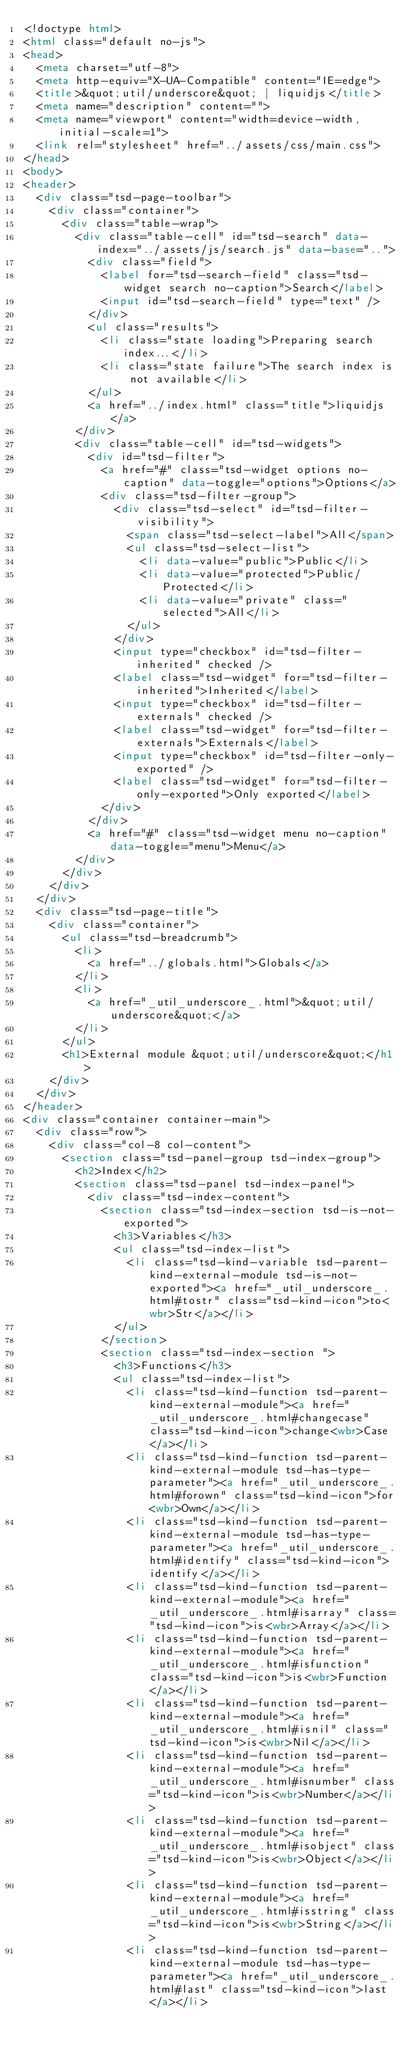<code> <loc_0><loc_0><loc_500><loc_500><_HTML_><!doctype html>
<html class="default no-js">
<head>
	<meta charset="utf-8">
	<meta http-equiv="X-UA-Compatible" content="IE=edge">
	<title>&quot;util/underscore&quot; | liquidjs</title>
	<meta name="description" content="">
	<meta name="viewport" content="width=device-width, initial-scale=1">
	<link rel="stylesheet" href="../assets/css/main.css">
</head>
<body>
<header>
	<div class="tsd-page-toolbar">
		<div class="container">
			<div class="table-wrap">
				<div class="table-cell" id="tsd-search" data-index="../assets/js/search.js" data-base="..">
					<div class="field">
						<label for="tsd-search-field" class="tsd-widget search no-caption">Search</label>
						<input id="tsd-search-field" type="text" />
					</div>
					<ul class="results">
						<li class="state loading">Preparing search index...</li>
						<li class="state failure">The search index is not available</li>
					</ul>
					<a href="../index.html" class="title">liquidjs</a>
				</div>
				<div class="table-cell" id="tsd-widgets">
					<div id="tsd-filter">
						<a href="#" class="tsd-widget options no-caption" data-toggle="options">Options</a>
						<div class="tsd-filter-group">
							<div class="tsd-select" id="tsd-filter-visibility">
								<span class="tsd-select-label">All</span>
								<ul class="tsd-select-list">
									<li data-value="public">Public</li>
									<li data-value="protected">Public/Protected</li>
									<li data-value="private" class="selected">All</li>
								</ul>
							</div>
							<input type="checkbox" id="tsd-filter-inherited" checked />
							<label class="tsd-widget" for="tsd-filter-inherited">Inherited</label>
							<input type="checkbox" id="tsd-filter-externals" checked />
							<label class="tsd-widget" for="tsd-filter-externals">Externals</label>
							<input type="checkbox" id="tsd-filter-only-exported" />
							<label class="tsd-widget" for="tsd-filter-only-exported">Only exported</label>
						</div>
					</div>
					<a href="#" class="tsd-widget menu no-caption" data-toggle="menu">Menu</a>
				</div>
			</div>
		</div>
	</div>
	<div class="tsd-page-title">
		<div class="container">
			<ul class="tsd-breadcrumb">
				<li>
					<a href="../globals.html">Globals</a>
				</li>
				<li>
					<a href="_util_underscore_.html">&quot;util/underscore&quot;</a>
				</li>
			</ul>
			<h1>External module &quot;util/underscore&quot;</h1>
		</div>
	</div>
</header>
<div class="container container-main">
	<div class="row">
		<div class="col-8 col-content">
			<section class="tsd-panel-group tsd-index-group">
				<h2>Index</h2>
				<section class="tsd-panel tsd-index-panel">
					<div class="tsd-index-content">
						<section class="tsd-index-section tsd-is-not-exported">
							<h3>Variables</h3>
							<ul class="tsd-index-list">
								<li class="tsd-kind-variable tsd-parent-kind-external-module tsd-is-not-exported"><a href="_util_underscore_.html#tostr" class="tsd-kind-icon">to<wbr>Str</a></li>
							</ul>
						</section>
						<section class="tsd-index-section ">
							<h3>Functions</h3>
							<ul class="tsd-index-list">
								<li class="tsd-kind-function tsd-parent-kind-external-module"><a href="_util_underscore_.html#changecase" class="tsd-kind-icon">change<wbr>Case</a></li>
								<li class="tsd-kind-function tsd-parent-kind-external-module tsd-has-type-parameter"><a href="_util_underscore_.html#forown" class="tsd-kind-icon">for<wbr>Own</a></li>
								<li class="tsd-kind-function tsd-parent-kind-external-module tsd-has-type-parameter"><a href="_util_underscore_.html#identify" class="tsd-kind-icon">identify</a></li>
								<li class="tsd-kind-function tsd-parent-kind-external-module"><a href="_util_underscore_.html#isarray" class="tsd-kind-icon">is<wbr>Array</a></li>
								<li class="tsd-kind-function tsd-parent-kind-external-module"><a href="_util_underscore_.html#isfunction" class="tsd-kind-icon">is<wbr>Function</a></li>
								<li class="tsd-kind-function tsd-parent-kind-external-module"><a href="_util_underscore_.html#isnil" class="tsd-kind-icon">is<wbr>Nil</a></li>
								<li class="tsd-kind-function tsd-parent-kind-external-module"><a href="_util_underscore_.html#isnumber" class="tsd-kind-icon">is<wbr>Number</a></li>
								<li class="tsd-kind-function tsd-parent-kind-external-module"><a href="_util_underscore_.html#isobject" class="tsd-kind-icon">is<wbr>Object</a></li>
								<li class="tsd-kind-function tsd-parent-kind-external-module"><a href="_util_underscore_.html#isstring" class="tsd-kind-icon">is<wbr>String</a></li>
								<li class="tsd-kind-function tsd-parent-kind-external-module tsd-has-type-parameter"><a href="_util_underscore_.html#last" class="tsd-kind-icon">last</a></li></code> 